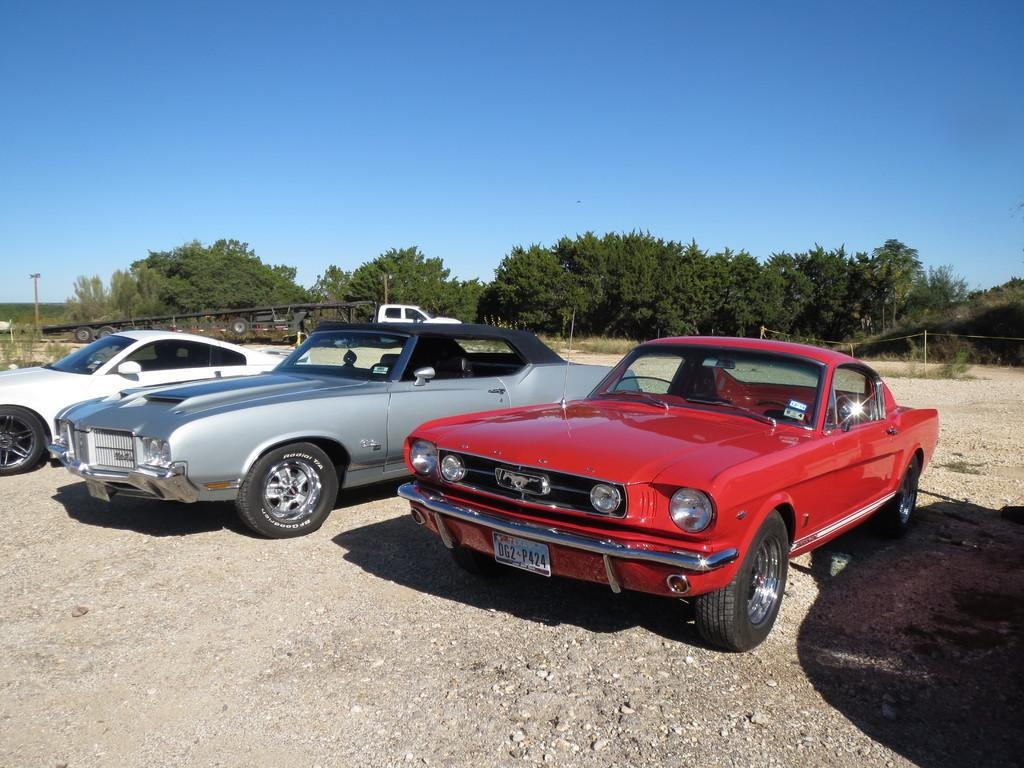What can be seen on the road in the image? There are cars on the road in the image. What is located on the right side of the image? There is a fence on the right side of the image. What type of vegetation is visible in the background of the image? There are trees in the background of the image. What is visible in the sky in the image? The sky is visible in the background of the image. How many cows are grazing in the image? There are no cows present in the image. Can you tell me how many frogs are hopping on the fence in the image? There are no frogs present in the image. 